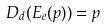<formula> <loc_0><loc_0><loc_500><loc_500>D _ { d } ( E _ { e } ( p ) ) = p</formula> 